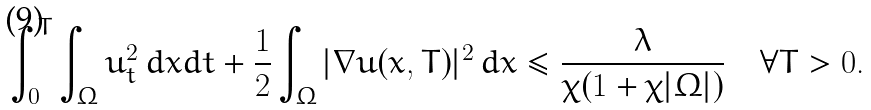Convert formula to latex. <formula><loc_0><loc_0><loc_500><loc_500>\int _ { 0 } ^ { T } \int _ { \Omega } u _ { t } ^ { 2 } \, d x d t + \frac { 1 } { 2 } \int _ { \Omega } | \nabla u ( x , T ) | ^ { 2 } \, d x \leq \frac { \lambda } { \chi ( 1 + \chi | \Omega | ) } \quad \forall T > 0 .</formula> 